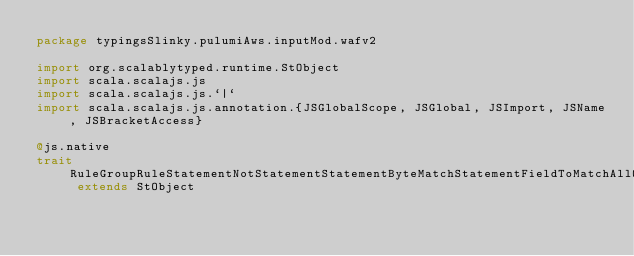<code> <loc_0><loc_0><loc_500><loc_500><_Scala_>package typingsSlinky.pulumiAws.inputMod.wafv2

import org.scalablytyped.runtime.StObject
import scala.scalajs.js
import scala.scalajs.js.`|`
import scala.scalajs.js.annotation.{JSGlobalScope, JSGlobal, JSImport, JSName, JSBracketAccess}

@js.native
trait RuleGroupRuleStatementNotStatementStatementByteMatchStatementFieldToMatchAllQueryArguments extends StObject
</code> 